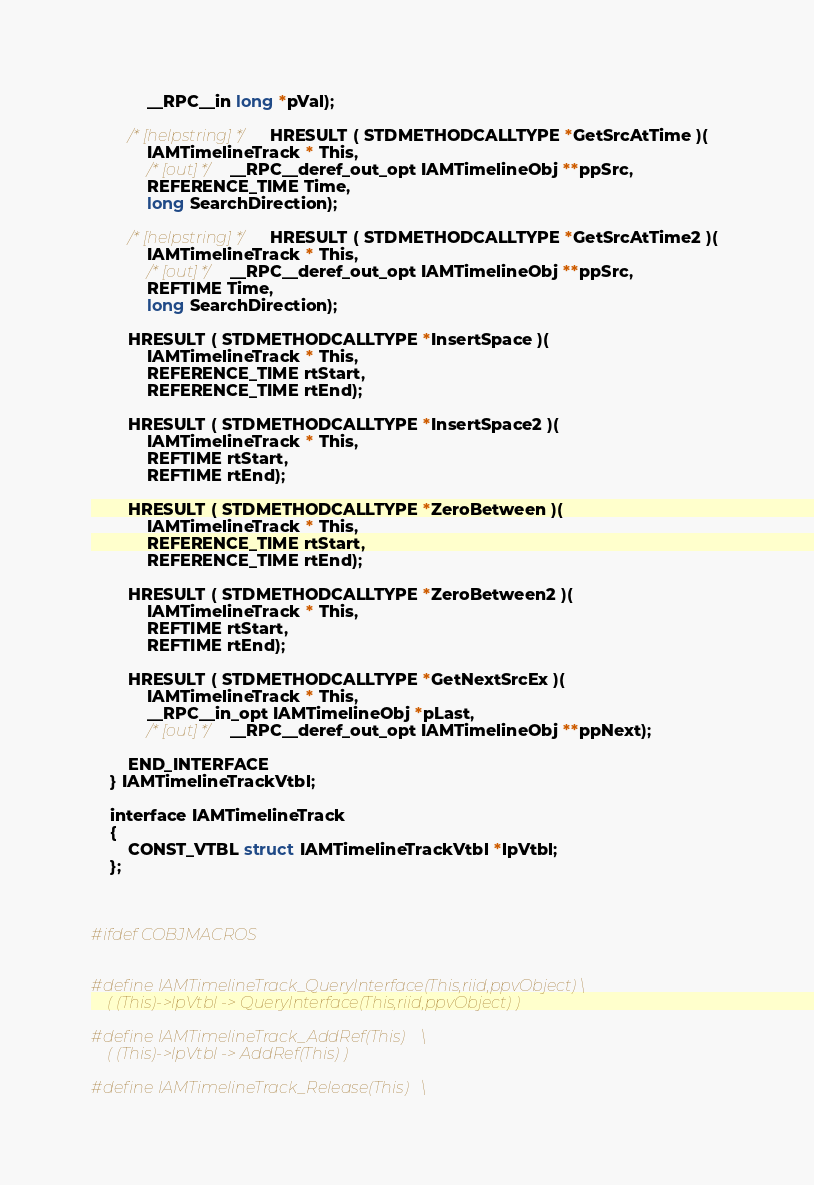<code> <loc_0><loc_0><loc_500><loc_500><_C_>            __RPC__in long *pVal);
        
        /* [helpstring] */ HRESULT ( STDMETHODCALLTYPE *GetSrcAtTime )( 
            IAMTimelineTrack * This,
            /* [out] */ __RPC__deref_out_opt IAMTimelineObj **ppSrc,
            REFERENCE_TIME Time,
            long SearchDirection);
        
        /* [helpstring] */ HRESULT ( STDMETHODCALLTYPE *GetSrcAtTime2 )( 
            IAMTimelineTrack * This,
            /* [out] */ __RPC__deref_out_opt IAMTimelineObj **ppSrc,
            REFTIME Time,
            long SearchDirection);
        
        HRESULT ( STDMETHODCALLTYPE *InsertSpace )( 
            IAMTimelineTrack * This,
            REFERENCE_TIME rtStart,
            REFERENCE_TIME rtEnd);
        
        HRESULT ( STDMETHODCALLTYPE *InsertSpace2 )( 
            IAMTimelineTrack * This,
            REFTIME rtStart,
            REFTIME rtEnd);
        
        HRESULT ( STDMETHODCALLTYPE *ZeroBetween )( 
            IAMTimelineTrack * This,
            REFERENCE_TIME rtStart,
            REFERENCE_TIME rtEnd);
        
        HRESULT ( STDMETHODCALLTYPE *ZeroBetween2 )( 
            IAMTimelineTrack * This,
            REFTIME rtStart,
            REFTIME rtEnd);
        
        HRESULT ( STDMETHODCALLTYPE *GetNextSrcEx )( 
            IAMTimelineTrack * This,
            __RPC__in_opt IAMTimelineObj *pLast,
            /* [out] */ __RPC__deref_out_opt IAMTimelineObj **ppNext);
        
        END_INTERFACE
    } IAMTimelineTrackVtbl;

    interface IAMTimelineTrack
    {
        CONST_VTBL struct IAMTimelineTrackVtbl *lpVtbl;
    };

    

#ifdef COBJMACROS


#define IAMTimelineTrack_QueryInterface(This,riid,ppvObject)	\
    ( (This)->lpVtbl -> QueryInterface(This,riid,ppvObject) ) 

#define IAMTimelineTrack_AddRef(This)	\
    ( (This)->lpVtbl -> AddRef(This) ) 

#define IAMTimelineTrack_Release(This)	\</code> 